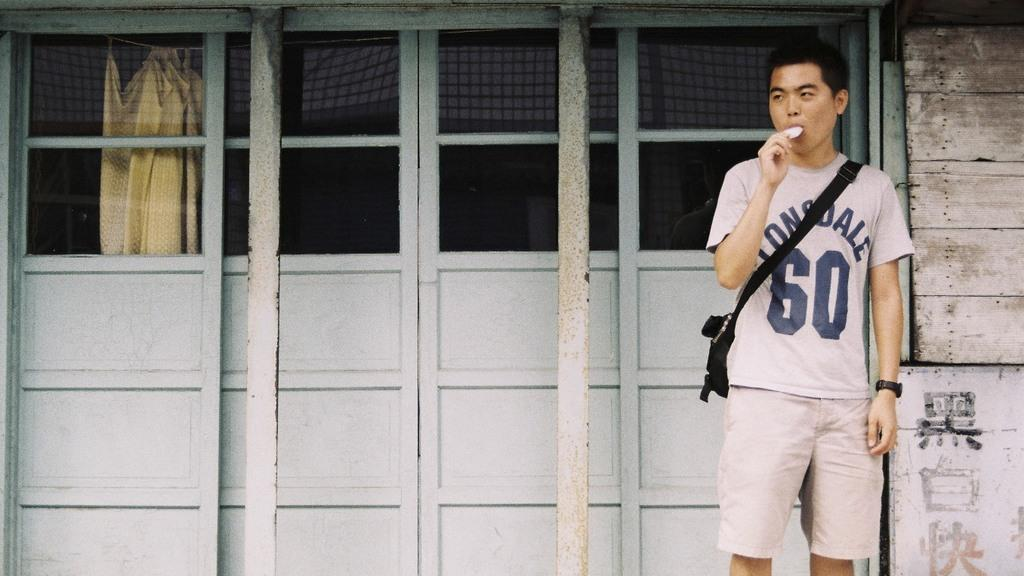<image>
Relay a brief, clear account of the picture shown. A man eating outside wearing a shirt that says lonsdale 60. 